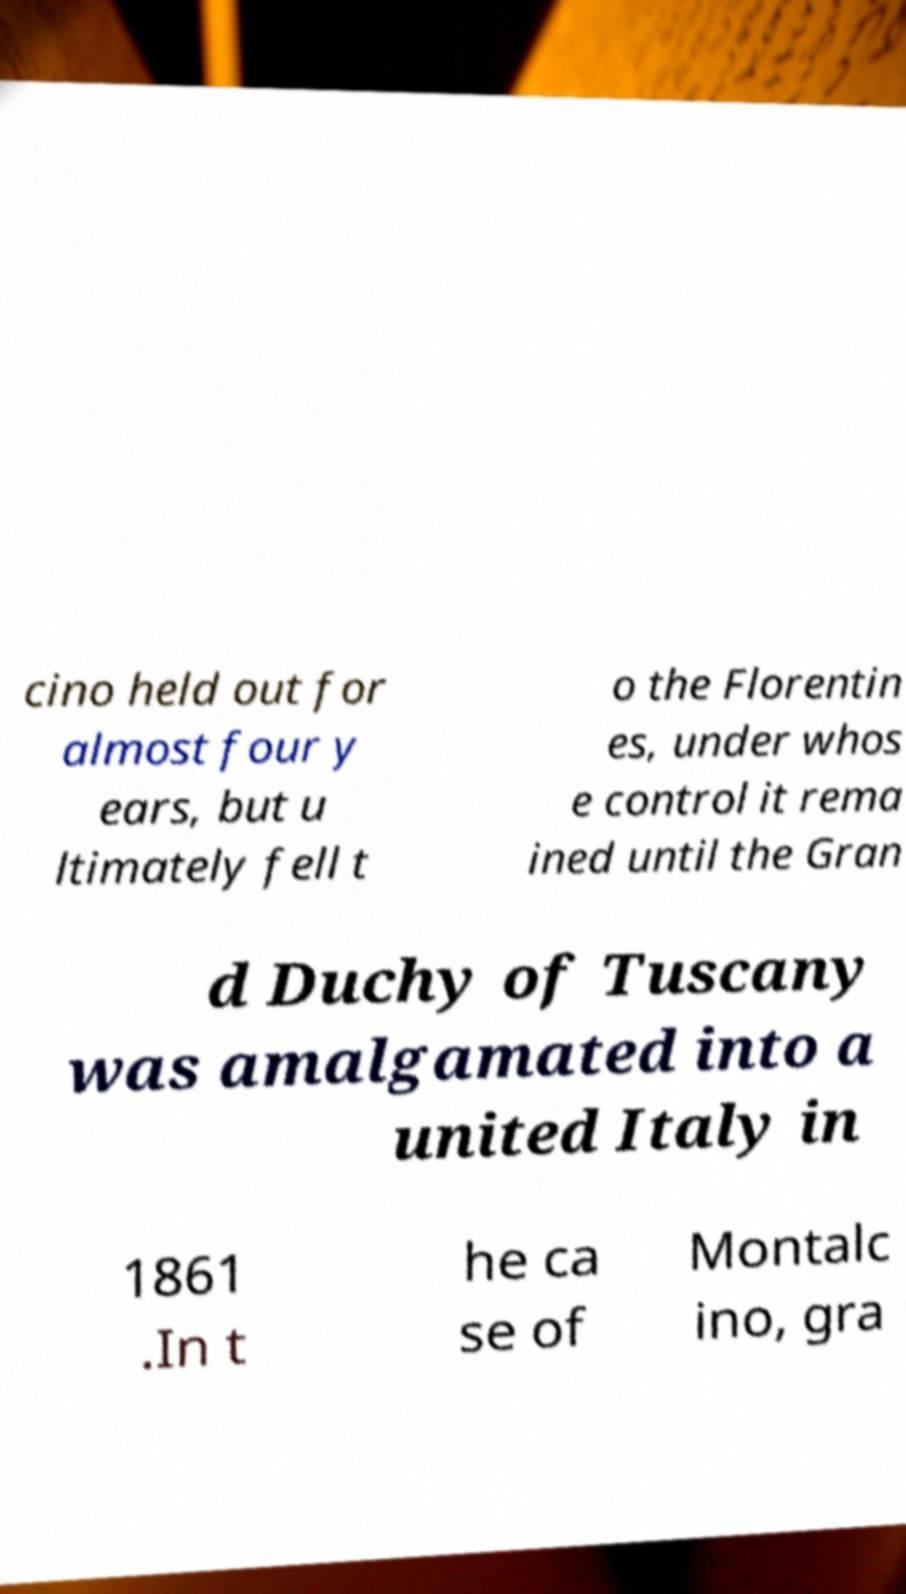Can you accurately transcribe the text from the provided image for me? cino held out for almost four y ears, but u ltimately fell t o the Florentin es, under whos e control it rema ined until the Gran d Duchy of Tuscany was amalgamated into a united Italy in 1861 .In t he ca se of Montalc ino, gra 